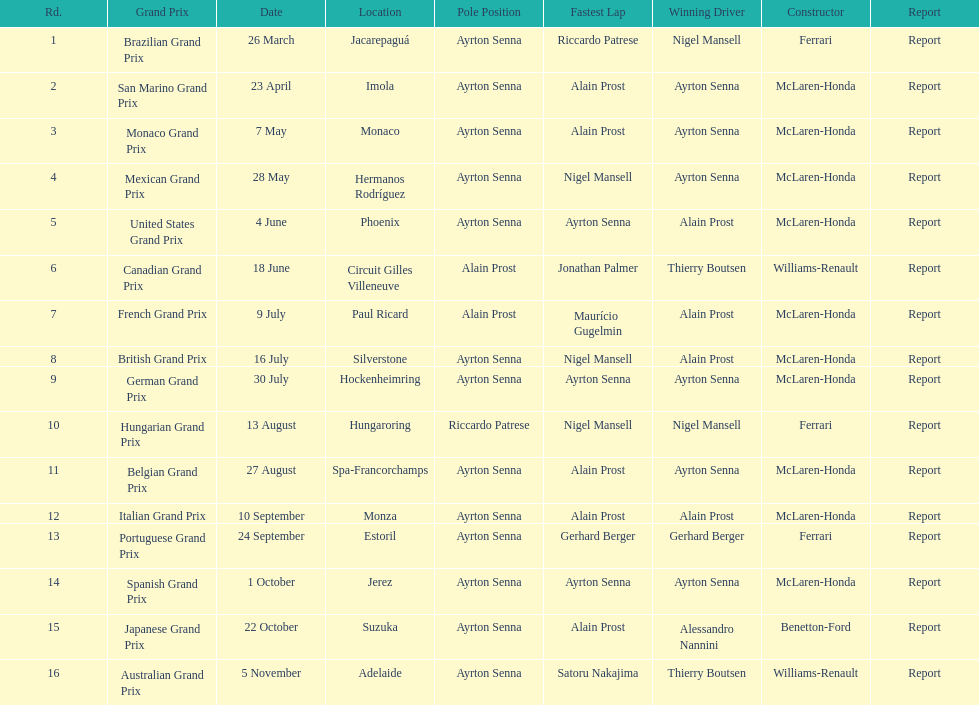Who was the victor of the spanish grand prix? McLaren-Honda. Who triumphed in the italian grand prix? McLaren-Honda. Which grand prix did benneton-ford secure victory in? Japanese Grand Prix. 